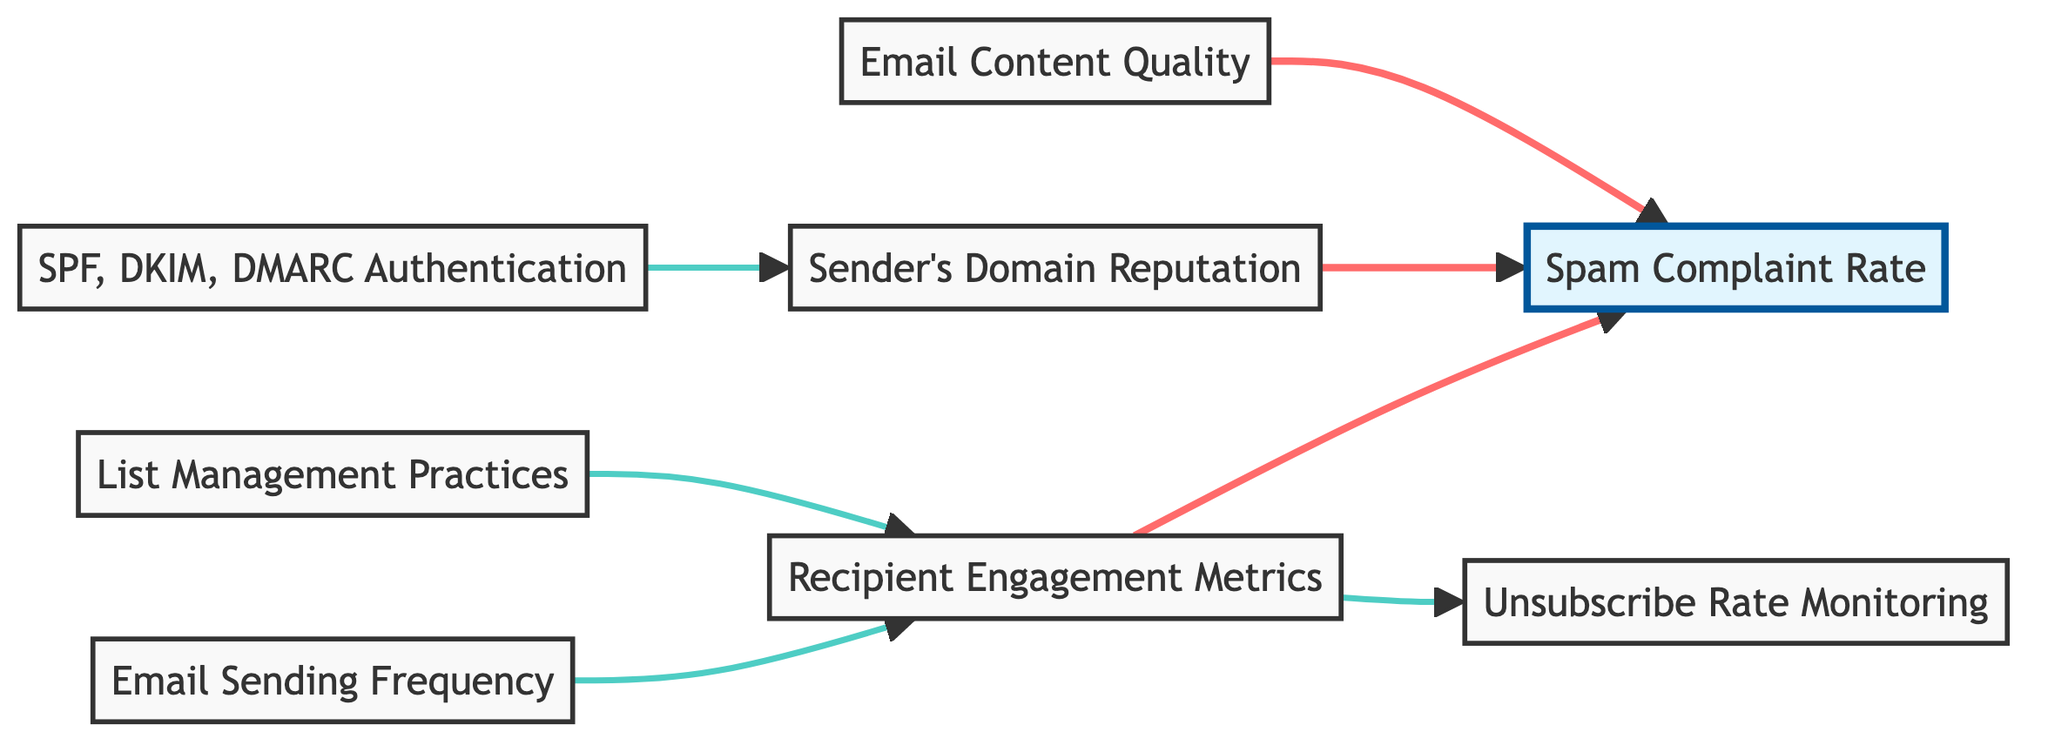What is the total number of nodes in the diagram? The diagram contains eight nodes, which are Email Content Quality, Sender's Domain Reputation, SPF, DKIM, DMARC Authentication, List Management Practices, Recipient Engagement Metrics, Unsubscribe Rate Monitoring, Spam Complaint Rate, and Email Sending Frequency.
Answer: 8 Which node directly influences Spam Complaint Rate? The diagram shows two nodes that directly point to Spam Complaint Rate: Email Content Quality and Sender's Domain Reputation, indicating that both have a direct impact on the rate of complaints filed as spam.
Answer: Email Content Quality, Sender's Domain Reputation How many edges connect to Engagement Metrics? The diagram displays three edges that come into Engagement Metrics, linking it to List Management Practices, Sending Frequency, and pointing to the downstream nodes of Spam Complaint Rate and Unsubscribe Rate, thus indicating multiple dependencies.
Answer: 3 What impact does Sending Frequency have on Engagement Metrics? Sending Frequency directly influences Engagement Metrics, as depicted by an edge that connects them in the diagram, indicating that how often emails are sent has a role in how recipients engage with them.
Answer: Positive Impact Which authentication techniques contribute to Sender's Domain Reputation? The diagram indicates that SPF, DKIM, DMARC Authentication contributes to improving Sender's Domain Reputation through a directed edge that signifies a relationship, indicating that these techniques enhance trustworthiness.
Answer: SPF, DKIM, DMARC What is the relationship between Engagement Metrics and Unsubscribe Rate? Engagement Metrics has a direct impact on Unsubscribe Rate, as indicated by an edge pointing from Engagement Metrics to Unsubscribe Rate, showing that higher engagement likely affects how often users opt out of receiving emails.
Answer: Direct Impact Is there a direct relationship between List Management Practices and Spam Complaint Rate? There is no direct edge connecting List Management Practices to Spam Complaint Rate in the diagram, which indicates that while List Management may influence engagement, it does not directly affect how often emails are marked as spam.
Answer: No Which node has the highest number of outgoing edges? The Engagement Metrics node has two outgoing edges, as it connects to both Spam Complaint Rate and Unsubscribe Rate, indicating it has multiple effects within the email sending process.
Answer: Engagement Metrics 